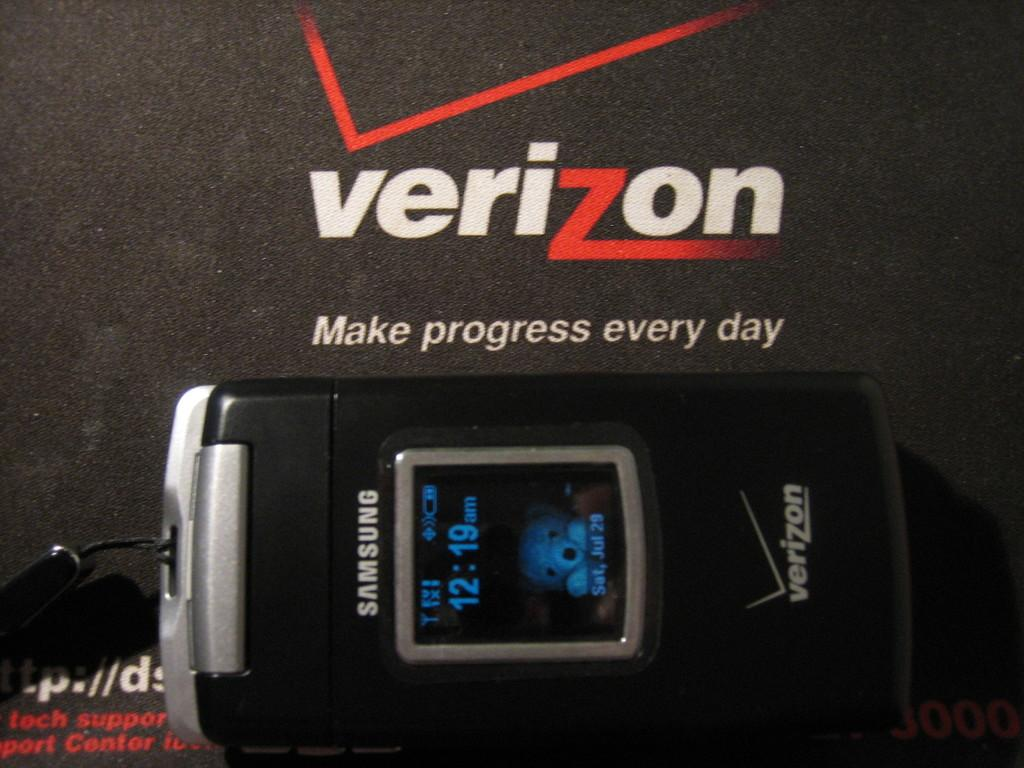<image>
Share a concise interpretation of the image provided. A phone is laying on its side under a Verizon logo. 